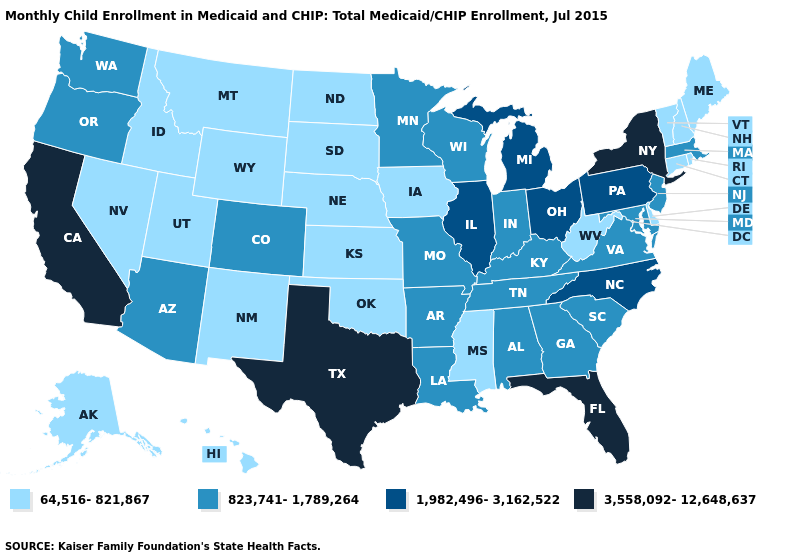Does the first symbol in the legend represent the smallest category?
Short answer required. Yes. What is the value of Delaware?
Keep it brief. 64,516-821,867. Which states hav the highest value in the Northeast?
Give a very brief answer. New York. Name the states that have a value in the range 823,741-1,789,264?
Keep it brief. Alabama, Arizona, Arkansas, Colorado, Georgia, Indiana, Kentucky, Louisiana, Maryland, Massachusetts, Minnesota, Missouri, New Jersey, Oregon, South Carolina, Tennessee, Virginia, Washington, Wisconsin. What is the value of Kentucky?
Write a very short answer. 823,741-1,789,264. Among the states that border Iowa , does Nebraska have the lowest value?
Answer briefly. Yes. Which states have the lowest value in the MidWest?
Be succinct. Iowa, Kansas, Nebraska, North Dakota, South Dakota. Does the map have missing data?
Answer briefly. No. What is the highest value in the West ?
Concise answer only. 3,558,092-12,648,637. Name the states that have a value in the range 3,558,092-12,648,637?
Be succinct. California, Florida, New York, Texas. Does the first symbol in the legend represent the smallest category?
Write a very short answer. Yes. Does the first symbol in the legend represent the smallest category?
Quick response, please. Yes. Does Nevada have the same value as Oregon?
Write a very short answer. No. Does Connecticut have the highest value in the Northeast?
Write a very short answer. No. Name the states that have a value in the range 64,516-821,867?
Concise answer only. Alaska, Connecticut, Delaware, Hawaii, Idaho, Iowa, Kansas, Maine, Mississippi, Montana, Nebraska, Nevada, New Hampshire, New Mexico, North Dakota, Oklahoma, Rhode Island, South Dakota, Utah, Vermont, West Virginia, Wyoming. 